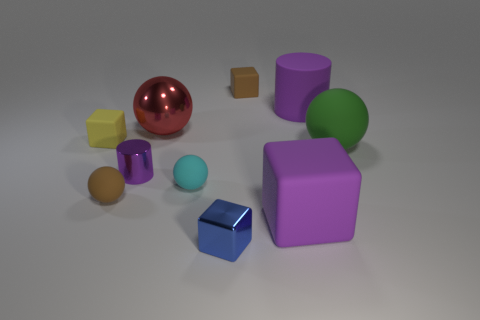Subtract 1 blocks. How many blocks are left? 3 Subtract all cubes. How many objects are left? 6 Add 6 big shiny things. How many big shiny things are left? 7 Add 1 large green matte objects. How many large green matte objects exist? 2 Subtract 0 blue spheres. How many objects are left? 10 Subtract all blue metal cubes. Subtract all blocks. How many objects are left? 5 